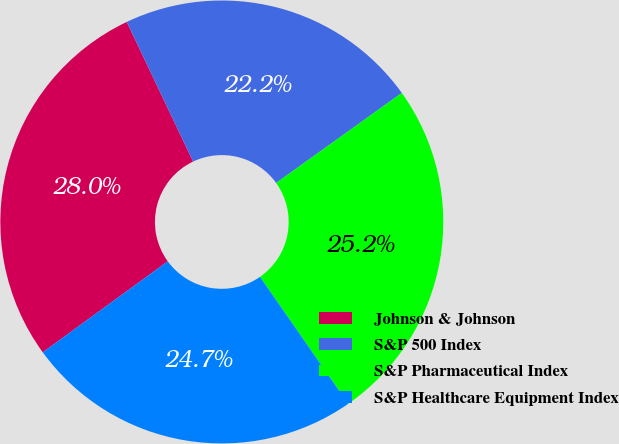Convert chart. <chart><loc_0><loc_0><loc_500><loc_500><pie_chart><fcel>Johnson & Johnson<fcel>S&P 500 Index<fcel>S&P Pharmaceutical Index<fcel>S&P Healthcare Equipment Index<nl><fcel>27.95%<fcel>22.16%<fcel>25.23%<fcel>24.65%<nl></chart> 